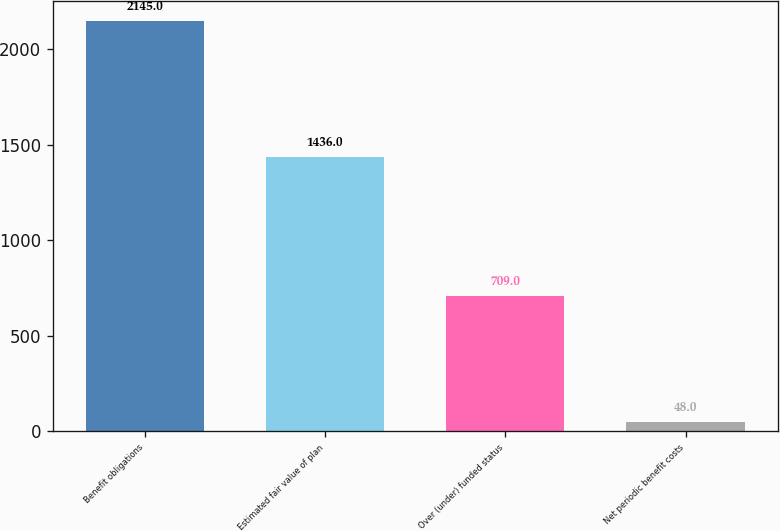Convert chart to OTSL. <chart><loc_0><loc_0><loc_500><loc_500><bar_chart><fcel>Benefit obligations<fcel>Estimated fair value of plan<fcel>Over (under) funded status<fcel>Net periodic benefit costs<nl><fcel>2145<fcel>1436<fcel>709<fcel>48<nl></chart> 